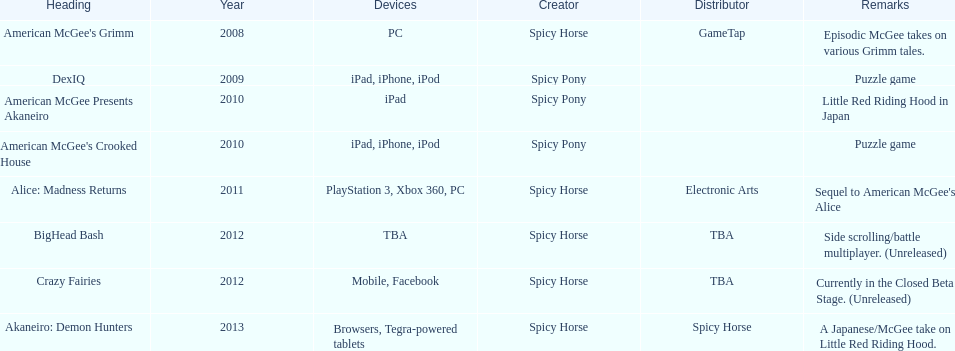How many platforms did american mcgee's grimm run on? 1. 